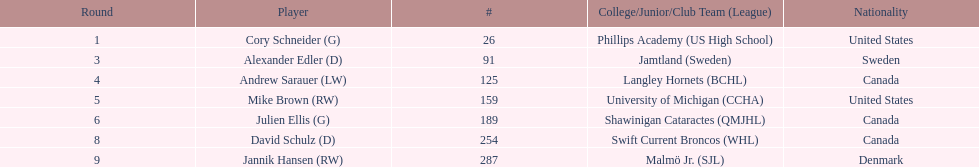Which player has canadian nationality and attended langley hornets? Andrew Sarauer (LW). 